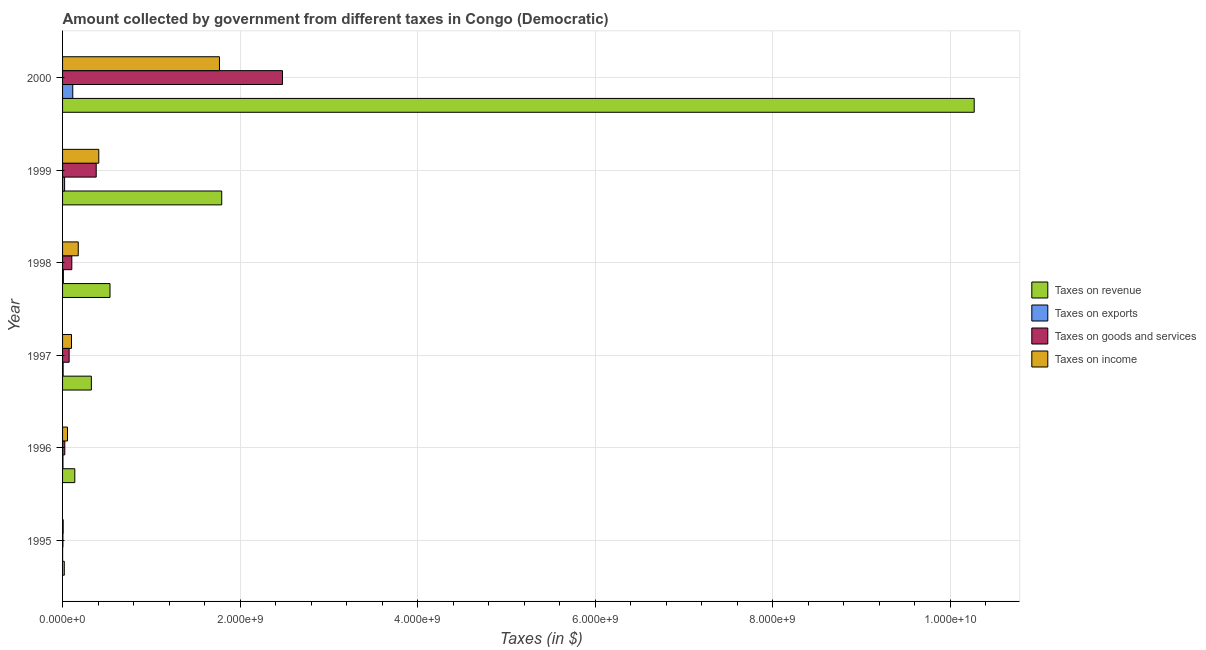How many groups of bars are there?
Your response must be concise. 6. Are the number of bars per tick equal to the number of legend labels?
Provide a short and direct response. Yes. Are the number of bars on each tick of the Y-axis equal?
Your response must be concise. Yes. How many bars are there on the 3rd tick from the top?
Your response must be concise. 4. How many bars are there on the 5th tick from the bottom?
Ensure brevity in your answer.  4. What is the amount collected as tax on revenue in 1996?
Keep it short and to the point. 1.38e+08. Across all years, what is the maximum amount collected as tax on goods?
Provide a short and direct response. 2.48e+09. Across all years, what is the minimum amount collected as tax on goods?
Provide a short and direct response. 3.96e+06. What is the total amount collected as tax on revenue in the graph?
Make the answer very short. 1.31e+1. What is the difference between the amount collected as tax on income in 1996 and that in 1997?
Make the answer very short. -4.52e+07. What is the difference between the amount collected as tax on exports in 1998 and the amount collected as tax on revenue in 1996?
Give a very brief answer. -1.29e+08. What is the average amount collected as tax on exports per year?
Ensure brevity in your answer.  2.64e+07. In the year 1996, what is the difference between the amount collected as tax on income and amount collected as tax on goods?
Provide a short and direct response. 3.03e+07. In how many years, is the amount collected as tax on income greater than 8800000000 $?
Ensure brevity in your answer.  0. What is the ratio of the amount collected as tax on revenue in 1997 to that in 2000?
Offer a very short reply. 0.03. Is the amount collected as tax on exports in 1996 less than that in 1998?
Your answer should be very brief. Yes. What is the difference between the highest and the second highest amount collected as tax on goods?
Keep it short and to the point. 2.10e+09. What is the difference between the highest and the lowest amount collected as tax on income?
Your answer should be compact. 1.76e+09. Is the sum of the amount collected as tax on revenue in 1995 and 1999 greater than the maximum amount collected as tax on income across all years?
Provide a succinct answer. Yes. What does the 4th bar from the top in 1995 represents?
Make the answer very short. Taxes on revenue. What does the 2nd bar from the bottom in 1998 represents?
Provide a succinct answer. Taxes on exports. Is it the case that in every year, the sum of the amount collected as tax on revenue and amount collected as tax on exports is greater than the amount collected as tax on goods?
Offer a very short reply. Yes. How many bars are there?
Ensure brevity in your answer.  24. Are all the bars in the graph horizontal?
Offer a very short reply. Yes. How many years are there in the graph?
Provide a short and direct response. 6. Are the values on the major ticks of X-axis written in scientific E-notation?
Give a very brief answer. Yes. Does the graph contain grids?
Keep it short and to the point. Yes. Where does the legend appear in the graph?
Ensure brevity in your answer.  Center right. What is the title of the graph?
Offer a very short reply. Amount collected by government from different taxes in Congo (Democratic). Does "Finland" appear as one of the legend labels in the graph?
Provide a short and direct response. No. What is the label or title of the X-axis?
Ensure brevity in your answer.  Taxes (in $). What is the Taxes (in $) of Taxes on revenue in 1995?
Give a very brief answer. 1.96e+07. What is the Taxes (in $) in Taxes on goods and services in 1995?
Offer a terse response. 3.96e+06. What is the Taxes (in $) in Taxes on revenue in 1996?
Offer a terse response. 1.38e+08. What is the Taxes (in $) in Taxes on exports in 1996?
Your answer should be compact. 4.53e+06. What is the Taxes (in $) of Taxes on goods and services in 1996?
Give a very brief answer. 2.52e+07. What is the Taxes (in $) of Taxes on income in 1996?
Give a very brief answer. 5.55e+07. What is the Taxes (in $) of Taxes on revenue in 1997?
Your answer should be very brief. 3.24e+08. What is the Taxes (in $) in Taxes on exports in 1997?
Offer a very short reply. 6.24e+06. What is the Taxes (in $) in Taxes on goods and services in 1997?
Ensure brevity in your answer.  7.41e+07. What is the Taxes (in $) of Taxes on income in 1997?
Give a very brief answer. 1.01e+08. What is the Taxes (in $) in Taxes on revenue in 1998?
Keep it short and to the point. 5.34e+08. What is the Taxes (in $) of Taxes on exports in 1998?
Provide a short and direct response. 9.11e+06. What is the Taxes (in $) of Taxes on goods and services in 1998?
Offer a terse response. 1.04e+08. What is the Taxes (in $) in Taxes on income in 1998?
Make the answer very short. 1.77e+08. What is the Taxes (in $) of Taxes on revenue in 1999?
Offer a very short reply. 1.79e+09. What is the Taxes (in $) in Taxes on exports in 1999?
Ensure brevity in your answer.  2.30e+07. What is the Taxes (in $) of Taxes on goods and services in 1999?
Offer a terse response. 3.79e+08. What is the Taxes (in $) of Taxes on income in 1999?
Keep it short and to the point. 4.08e+08. What is the Taxes (in $) in Taxes on revenue in 2000?
Give a very brief answer. 1.03e+1. What is the Taxes (in $) in Taxes on exports in 2000?
Your response must be concise. 1.15e+08. What is the Taxes (in $) in Taxes on goods and services in 2000?
Offer a terse response. 2.48e+09. What is the Taxes (in $) in Taxes on income in 2000?
Offer a very short reply. 1.77e+09. Across all years, what is the maximum Taxes (in $) of Taxes on revenue?
Provide a succinct answer. 1.03e+1. Across all years, what is the maximum Taxes (in $) in Taxes on exports?
Make the answer very short. 1.15e+08. Across all years, what is the maximum Taxes (in $) in Taxes on goods and services?
Your response must be concise. 2.48e+09. Across all years, what is the maximum Taxes (in $) in Taxes on income?
Ensure brevity in your answer.  1.77e+09. Across all years, what is the minimum Taxes (in $) in Taxes on revenue?
Offer a terse response. 1.96e+07. Across all years, what is the minimum Taxes (in $) of Taxes on goods and services?
Provide a succinct answer. 3.96e+06. Across all years, what is the minimum Taxes (in $) in Taxes on income?
Your answer should be very brief. 7.00e+06. What is the total Taxes (in $) of Taxes on revenue in the graph?
Make the answer very short. 1.31e+1. What is the total Taxes (in $) of Taxes on exports in the graph?
Provide a succinct answer. 1.58e+08. What is the total Taxes (in $) in Taxes on goods and services in the graph?
Provide a succinct answer. 3.06e+09. What is the total Taxes (in $) in Taxes on income in the graph?
Give a very brief answer. 2.52e+09. What is the difference between the Taxes (in $) in Taxes on revenue in 1995 and that in 1996?
Give a very brief answer. -1.18e+08. What is the difference between the Taxes (in $) in Taxes on exports in 1995 and that in 1996?
Your answer should be very brief. -4.03e+06. What is the difference between the Taxes (in $) in Taxes on goods and services in 1995 and that in 1996?
Provide a succinct answer. -2.12e+07. What is the difference between the Taxes (in $) of Taxes on income in 1995 and that in 1996?
Your answer should be very brief. -4.85e+07. What is the difference between the Taxes (in $) of Taxes on revenue in 1995 and that in 1997?
Provide a short and direct response. -3.05e+08. What is the difference between the Taxes (in $) of Taxes on exports in 1995 and that in 1997?
Make the answer very short. -5.74e+06. What is the difference between the Taxes (in $) of Taxes on goods and services in 1995 and that in 1997?
Give a very brief answer. -7.01e+07. What is the difference between the Taxes (in $) in Taxes on income in 1995 and that in 1997?
Make the answer very short. -9.37e+07. What is the difference between the Taxes (in $) of Taxes on revenue in 1995 and that in 1998?
Give a very brief answer. -5.15e+08. What is the difference between the Taxes (in $) in Taxes on exports in 1995 and that in 1998?
Your answer should be very brief. -8.61e+06. What is the difference between the Taxes (in $) in Taxes on goods and services in 1995 and that in 1998?
Your answer should be very brief. -1.00e+08. What is the difference between the Taxes (in $) of Taxes on income in 1995 and that in 1998?
Give a very brief answer. -1.70e+08. What is the difference between the Taxes (in $) of Taxes on revenue in 1995 and that in 1999?
Provide a succinct answer. -1.77e+09. What is the difference between the Taxes (in $) of Taxes on exports in 1995 and that in 1999?
Make the answer very short. -2.25e+07. What is the difference between the Taxes (in $) in Taxes on goods and services in 1995 and that in 1999?
Your answer should be very brief. -3.75e+08. What is the difference between the Taxes (in $) in Taxes on income in 1995 and that in 1999?
Your answer should be very brief. -4.01e+08. What is the difference between the Taxes (in $) in Taxes on revenue in 1995 and that in 2000?
Your answer should be compact. -1.02e+1. What is the difference between the Taxes (in $) in Taxes on exports in 1995 and that in 2000?
Offer a very short reply. -1.14e+08. What is the difference between the Taxes (in $) of Taxes on goods and services in 1995 and that in 2000?
Your answer should be compact. -2.47e+09. What is the difference between the Taxes (in $) in Taxes on income in 1995 and that in 2000?
Keep it short and to the point. -1.76e+09. What is the difference between the Taxes (in $) in Taxes on revenue in 1996 and that in 1997?
Ensure brevity in your answer.  -1.86e+08. What is the difference between the Taxes (in $) of Taxes on exports in 1996 and that in 1997?
Make the answer very short. -1.71e+06. What is the difference between the Taxes (in $) in Taxes on goods and services in 1996 and that in 1997?
Offer a terse response. -4.89e+07. What is the difference between the Taxes (in $) in Taxes on income in 1996 and that in 1997?
Give a very brief answer. -4.52e+07. What is the difference between the Taxes (in $) of Taxes on revenue in 1996 and that in 1998?
Make the answer very short. -3.97e+08. What is the difference between the Taxes (in $) of Taxes on exports in 1996 and that in 1998?
Offer a very short reply. -4.58e+06. What is the difference between the Taxes (in $) in Taxes on goods and services in 1996 and that in 1998?
Provide a short and direct response. -7.90e+07. What is the difference between the Taxes (in $) of Taxes on income in 1996 and that in 1998?
Make the answer very short. -1.21e+08. What is the difference between the Taxes (in $) in Taxes on revenue in 1996 and that in 1999?
Provide a short and direct response. -1.66e+09. What is the difference between the Taxes (in $) of Taxes on exports in 1996 and that in 1999?
Your answer should be compact. -1.85e+07. What is the difference between the Taxes (in $) of Taxes on goods and services in 1996 and that in 1999?
Your answer should be very brief. -3.54e+08. What is the difference between the Taxes (in $) of Taxes on income in 1996 and that in 1999?
Provide a succinct answer. -3.52e+08. What is the difference between the Taxes (in $) of Taxes on revenue in 1996 and that in 2000?
Make the answer very short. -1.01e+1. What is the difference between the Taxes (in $) of Taxes on exports in 1996 and that in 2000?
Your answer should be very brief. -1.10e+08. What is the difference between the Taxes (in $) in Taxes on goods and services in 1996 and that in 2000?
Your answer should be compact. -2.45e+09. What is the difference between the Taxes (in $) in Taxes on income in 1996 and that in 2000?
Keep it short and to the point. -1.71e+09. What is the difference between the Taxes (in $) of Taxes on revenue in 1997 and that in 1998?
Offer a very short reply. -2.10e+08. What is the difference between the Taxes (in $) in Taxes on exports in 1997 and that in 1998?
Keep it short and to the point. -2.87e+06. What is the difference between the Taxes (in $) in Taxes on goods and services in 1997 and that in 1998?
Give a very brief answer. -3.02e+07. What is the difference between the Taxes (in $) in Taxes on income in 1997 and that in 1998?
Keep it short and to the point. -7.60e+07. What is the difference between the Taxes (in $) in Taxes on revenue in 1997 and that in 1999?
Ensure brevity in your answer.  -1.47e+09. What is the difference between the Taxes (in $) in Taxes on exports in 1997 and that in 1999?
Provide a short and direct response. -1.68e+07. What is the difference between the Taxes (in $) in Taxes on goods and services in 1997 and that in 1999?
Give a very brief answer. -3.05e+08. What is the difference between the Taxes (in $) of Taxes on income in 1997 and that in 1999?
Ensure brevity in your answer.  -3.07e+08. What is the difference between the Taxes (in $) in Taxes on revenue in 1997 and that in 2000?
Ensure brevity in your answer.  -9.94e+09. What is the difference between the Taxes (in $) of Taxes on exports in 1997 and that in 2000?
Your response must be concise. -1.09e+08. What is the difference between the Taxes (in $) in Taxes on goods and services in 1997 and that in 2000?
Your answer should be compact. -2.40e+09. What is the difference between the Taxes (in $) in Taxes on income in 1997 and that in 2000?
Your answer should be very brief. -1.67e+09. What is the difference between the Taxes (in $) of Taxes on revenue in 1998 and that in 1999?
Make the answer very short. -1.26e+09. What is the difference between the Taxes (in $) of Taxes on exports in 1998 and that in 1999?
Keep it short and to the point. -1.39e+07. What is the difference between the Taxes (in $) in Taxes on goods and services in 1998 and that in 1999?
Provide a succinct answer. -2.75e+08. What is the difference between the Taxes (in $) of Taxes on income in 1998 and that in 1999?
Provide a short and direct response. -2.31e+08. What is the difference between the Taxes (in $) of Taxes on revenue in 1998 and that in 2000?
Provide a succinct answer. -9.73e+09. What is the difference between the Taxes (in $) of Taxes on exports in 1998 and that in 2000?
Offer a terse response. -1.06e+08. What is the difference between the Taxes (in $) in Taxes on goods and services in 1998 and that in 2000?
Keep it short and to the point. -2.37e+09. What is the difference between the Taxes (in $) in Taxes on income in 1998 and that in 2000?
Keep it short and to the point. -1.59e+09. What is the difference between the Taxes (in $) of Taxes on revenue in 1999 and that in 2000?
Your response must be concise. -8.48e+09. What is the difference between the Taxes (in $) in Taxes on exports in 1999 and that in 2000?
Your answer should be compact. -9.19e+07. What is the difference between the Taxes (in $) in Taxes on goods and services in 1999 and that in 2000?
Offer a terse response. -2.10e+09. What is the difference between the Taxes (in $) in Taxes on income in 1999 and that in 2000?
Make the answer very short. -1.36e+09. What is the difference between the Taxes (in $) in Taxes on revenue in 1995 and the Taxes (in $) in Taxes on exports in 1996?
Provide a succinct answer. 1.50e+07. What is the difference between the Taxes (in $) of Taxes on revenue in 1995 and the Taxes (in $) of Taxes on goods and services in 1996?
Keep it short and to the point. -5.65e+06. What is the difference between the Taxes (in $) in Taxes on revenue in 1995 and the Taxes (in $) in Taxes on income in 1996?
Make the answer very short. -3.60e+07. What is the difference between the Taxes (in $) in Taxes on exports in 1995 and the Taxes (in $) in Taxes on goods and services in 1996?
Offer a very short reply. -2.47e+07. What is the difference between the Taxes (in $) of Taxes on exports in 1995 and the Taxes (in $) of Taxes on income in 1996?
Give a very brief answer. -5.50e+07. What is the difference between the Taxes (in $) of Taxes on goods and services in 1995 and the Taxes (in $) of Taxes on income in 1996?
Provide a succinct answer. -5.16e+07. What is the difference between the Taxes (in $) of Taxes on revenue in 1995 and the Taxes (in $) of Taxes on exports in 1997?
Provide a succinct answer. 1.33e+07. What is the difference between the Taxes (in $) of Taxes on revenue in 1995 and the Taxes (in $) of Taxes on goods and services in 1997?
Ensure brevity in your answer.  -5.45e+07. What is the difference between the Taxes (in $) of Taxes on revenue in 1995 and the Taxes (in $) of Taxes on income in 1997?
Your answer should be compact. -8.11e+07. What is the difference between the Taxes (in $) in Taxes on exports in 1995 and the Taxes (in $) in Taxes on goods and services in 1997?
Your response must be concise. -7.36e+07. What is the difference between the Taxes (in $) of Taxes on exports in 1995 and the Taxes (in $) of Taxes on income in 1997?
Your response must be concise. -1.00e+08. What is the difference between the Taxes (in $) in Taxes on goods and services in 1995 and the Taxes (in $) in Taxes on income in 1997?
Keep it short and to the point. -9.67e+07. What is the difference between the Taxes (in $) in Taxes on revenue in 1995 and the Taxes (in $) in Taxes on exports in 1998?
Keep it short and to the point. 1.04e+07. What is the difference between the Taxes (in $) in Taxes on revenue in 1995 and the Taxes (in $) in Taxes on goods and services in 1998?
Provide a succinct answer. -8.47e+07. What is the difference between the Taxes (in $) of Taxes on revenue in 1995 and the Taxes (in $) of Taxes on income in 1998?
Your response must be concise. -1.57e+08. What is the difference between the Taxes (in $) of Taxes on exports in 1995 and the Taxes (in $) of Taxes on goods and services in 1998?
Your answer should be very brief. -1.04e+08. What is the difference between the Taxes (in $) of Taxes on exports in 1995 and the Taxes (in $) of Taxes on income in 1998?
Provide a succinct answer. -1.76e+08. What is the difference between the Taxes (in $) in Taxes on goods and services in 1995 and the Taxes (in $) in Taxes on income in 1998?
Ensure brevity in your answer.  -1.73e+08. What is the difference between the Taxes (in $) in Taxes on revenue in 1995 and the Taxes (in $) in Taxes on exports in 1999?
Provide a short and direct response. -3.45e+06. What is the difference between the Taxes (in $) of Taxes on revenue in 1995 and the Taxes (in $) of Taxes on goods and services in 1999?
Your answer should be very brief. -3.59e+08. What is the difference between the Taxes (in $) of Taxes on revenue in 1995 and the Taxes (in $) of Taxes on income in 1999?
Provide a short and direct response. -3.88e+08. What is the difference between the Taxes (in $) in Taxes on exports in 1995 and the Taxes (in $) in Taxes on goods and services in 1999?
Your response must be concise. -3.78e+08. What is the difference between the Taxes (in $) of Taxes on exports in 1995 and the Taxes (in $) of Taxes on income in 1999?
Provide a succinct answer. -4.08e+08. What is the difference between the Taxes (in $) of Taxes on goods and services in 1995 and the Taxes (in $) of Taxes on income in 1999?
Give a very brief answer. -4.04e+08. What is the difference between the Taxes (in $) in Taxes on revenue in 1995 and the Taxes (in $) in Taxes on exports in 2000?
Your response must be concise. -9.53e+07. What is the difference between the Taxes (in $) in Taxes on revenue in 1995 and the Taxes (in $) in Taxes on goods and services in 2000?
Your response must be concise. -2.46e+09. What is the difference between the Taxes (in $) in Taxes on revenue in 1995 and the Taxes (in $) in Taxes on income in 2000?
Make the answer very short. -1.75e+09. What is the difference between the Taxes (in $) of Taxes on exports in 1995 and the Taxes (in $) of Taxes on goods and services in 2000?
Keep it short and to the point. -2.48e+09. What is the difference between the Taxes (in $) in Taxes on exports in 1995 and the Taxes (in $) in Taxes on income in 2000?
Give a very brief answer. -1.77e+09. What is the difference between the Taxes (in $) in Taxes on goods and services in 1995 and the Taxes (in $) in Taxes on income in 2000?
Offer a terse response. -1.76e+09. What is the difference between the Taxes (in $) in Taxes on revenue in 1996 and the Taxes (in $) in Taxes on exports in 1997?
Keep it short and to the point. 1.32e+08. What is the difference between the Taxes (in $) of Taxes on revenue in 1996 and the Taxes (in $) of Taxes on goods and services in 1997?
Ensure brevity in your answer.  6.38e+07. What is the difference between the Taxes (in $) of Taxes on revenue in 1996 and the Taxes (in $) of Taxes on income in 1997?
Provide a succinct answer. 3.72e+07. What is the difference between the Taxes (in $) of Taxes on exports in 1996 and the Taxes (in $) of Taxes on goods and services in 1997?
Provide a succinct answer. -6.95e+07. What is the difference between the Taxes (in $) of Taxes on exports in 1996 and the Taxes (in $) of Taxes on income in 1997?
Keep it short and to the point. -9.62e+07. What is the difference between the Taxes (in $) of Taxes on goods and services in 1996 and the Taxes (in $) of Taxes on income in 1997?
Make the answer very short. -7.55e+07. What is the difference between the Taxes (in $) in Taxes on revenue in 1996 and the Taxes (in $) in Taxes on exports in 1998?
Ensure brevity in your answer.  1.29e+08. What is the difference between the Taxes (in $) in Taxes on revenue in 1996 and the Taxes (in $) in Taxes on goods and services in 1998?
Offer a terse response. 3.36e+07. What is the difference between the Taxes (in $) of Taxes on revenue in 1996 and the Taxes (in $) of Taxes on income in 1998?
Give a very brief answer. -3.88e+07. What is the difference between the Taxes (in $) of Taxes on exports in 1996 and the Taxes (in $) of Taxes on goods and services in 1998?
Your answer should be very brief. -9.97e+07. What is the difference between the Taxes (in $) in Taxes on exports in 1996 and the Taxes (in $) in Taxes on income in 1998?
Your response must be concise. -1.72e+08. What is the difference between the Taxes (in $) in Taxes on goods and services in 1996 and the Taxes (in $) in Taxes on income in 1998?
Provide a short and direct response. -1.52e+08. What is the difference between the Taxes (in $) of Taxes on revenue in 1996 and the Taxes (in $) of Taxes on exports in 1999?
Provide a succinct answer. 1.15e+08. What is the difference between the Taxes (in $) in Taxes on revenue in 1996 and the Taxes (in $) in Taxes on goods and services in 1999?
Your answer should be very brief. -2.41e+08. What is the difference between the Taxes (in $) of Taxes on revenue in 1996 and the Taxes (in $) of Taxes on income in 1999?
Provide a succinct answer. -2.70e+08. What is the difference between the Taxes (in $) in Taxes on exports in 1996 and the Taxes (in $) in Taxes on goods and services in 1999?
Provide a succinct answer. -3.74e+08. What is the difference between the Taxes (in $) in Taxes on exports in 1996 and the Taxes (in $) in Taxes on income in 1999?
Give a very brief answer. -4.03e+08. What is the difference between the Taxes (in $) in Taxes on goods and services in 1996 and the Taxes (in $) in Taxes on income in 1999?
Your response must be concise. -3.83e+08. What is the difference between the Taxes (in $) of Taxes on revenue in 1996 and the Taxes (in $) of Taxes on exports in 2000?
Offer a very short reply. 2.30e+07. What is the difference between the Taxes (in $) of Taxes on revenue in 1996 and the Taxes (in $) of Taxes on goods and services in 2000?
Keep it short and to the point. -2.34e+09. What is the difference between the Taxes (in $) of Taxes on revenue in 1996 and the Taxes (in $) of Taxes on income in 2000?
Your answer should be compact. -1.63e+09. What is the difference between the Taxes (in $) in Taxes on exports in 1996 and the Taxes (in $) in Taxes on goods and services in 2000?
Provide a short and direct response. -2.47e+09. What is the difference between the Taxes (in $) of Taxes on exports in 1996 and the Taxes (in $) of Taxes on income in 2000?
Make the answer very short. -1.76e+09. What is the difference between the Taxes (in $) in Taxes on goods and services in 1996 and the Taxes (in $) in Taxes on income in 2000?
Ensure brevity in your answer.  -1.74e+09. What is the difference between the Taxes (in $) of Taxes on revenue in 1997 and the Taxes (in $) of Taxes on exports in 1998?
Your answer should be compact. 3.15e+08. What is the difference between the Taxes (in $) of Taxes on revenue in 1997 and the Taxes (in $) of Taxes on goods and services in 1998?
Your answer should be very brief. 2.20e+08. What is the difference between the Taxes (in $) of Taxes on revenue in 1997 and the Taxes (in $) of Taxes on income in 1998?
Offer a terse response. 1.48e+08. What is the difference between the Taxes (in $) of Taxes on exports in 1997 and the Taxes (in $) of Taxes on goods and services in 1998?
Your answer should be compact. -9.80e+07. What is the difference between the Taxes (in $) of Taxes on exports in 1997 and the Taxes (in $) of Taxes on income in 1998?
Your response must be concise. -1.70e+08. What is the difference between the Taxes (in $) in Taxes on goods and services in 1997 and the Taxes (in $) in Taxes on income in 1998?
Offer a terse response. -1.03e+08. What is the difference between the Taxes (in $) in Taxes on revenue in 1997 and the Taxes (in $) in Taxes on exports in 1999?
Give a very brief answer. 3.01e+08. What is the difference between the Taxes (in $) in Taxes on revenue in 1997 and the Taxes (in $) in Taxes on goods and services in 1999?
Your answer should be compact. -5.47e+07. What is the difference between the Taxes (in $) of Taxes on revenue in 1997 and the Taxes (in $) of Taxes on income in 1999?
Your response must be concise. -8.37e+07. What is the difference between the Taxes (in $) of Taxes on exports in 1997 and the Taxes (in $) of Taxes on goods and services in 1999?
Give a very brief answer. -3.73e+08. What is the difference between the Taxes (in $) of Taxes on exports in 1997 and the Taxes (in $) of Taxes on income in 1999?
Offer a terse response. -4.02e+08. What is the difference between the Taxes (in $) in Taxes on goods and services in 1997 and the Taxes (in $) in Taxes on income in 1999?
Give a very brief answer. -3.34e+08. What is the difference between the Taxes (in $) in Taxes on revenue in 1997 and the Taxes (in $) in Taxes on exports in 2000?
Your answer should be very brief. 2.09e+08. What is the difference between the Taxes (in $) of Taxes on revenue in 1997 and the Taxes (in $) of Taxes on goods and services in 2000?
Your answer should be very brief. -2.15e+09. What is the difference between the Taxes (in $) of Taxes on revenue in 1997 and the Taxes (in $) of Taxes on income in 2000?
Make the answer very short. -1.44e+09. What is the difference between the Taxes (in $) of Taxes on exports in 1997 and the Taxes (in $) of Taxes on goods and services in 2000?
Provide a short and direct response. -2.47e+09. What is the difference between the Taxes (in $) in Taxes on exports in 1997 and the Taxes (in $) in Taxes on income in 2000?
Give a very brief answer. -1.76e+09. What is the difference between the Taxes (in $) in Taxes on goods and services in 1997 and the Taxes (in $) in Taxes on income in 2000?
Provide a succinct answer. -1.69e+09. What is the difference between the Taxes (in $) of Taxes on revenue in 1998 and the Taxes (in $) of Taxes on exports in 1999?
Provide a succinct answer. 5.11e+08. What is the difference between the Taxes (in $) in Taxes on revenue in 1998 and the Taxes (in $) in Taxes on goods and services in 1999?
Your answer should be compact. 1.55e+08. What is the difference between the Taxes (in $) in Taxes on revenue in 1998 and the Taxes (in $) in Taxes on income in 1999?
Ensure brevity in your answer.  1.26e+08. What is the difference between the Taxes (in $) of Taxes on exports in 1998 and the Taxes (in $) of Taxes on goods and services in 1999?
Give a very brief answer. -3.70e+08. What is the difference between the Taxes (in $) of Taxes on exports in 1998 and the Taxes (in $) of Taxes on income in 1999?
Provide a succinct answer. -3.99e+08. What is the difference between the Taxes (in $) of Taxes on goods and services in 1998 and the Taxes (in $) of Taxes on income in 1999?
Provide a short and direct response. -3.04e+08. What is the difference between the Taxes (in $) of Taxes on revenue in 1998 and the Taxes (in $) of Taxes on exports in 2000?
Offer a terse response. 4.20e+08. What is the difference between the Taxes (in $) in Taxes on revenue in 1998 and the Taxes (in $) in Taxes on goods and services in 2000?
Your answer should be compact. -1.94e+09. What is the difference between the Taxes (in $) in Taxes on revenue in 1998 and the Taxes (in $) in Taxes on income in 2000?
Offer a very short reply. -1.23e+09. What is the difference between the Taxes (in $) in Taxes on exports in 1998 and the Taxes (in $) in Taxes on goods and services in 2000?
Ensure brevity in your answer.  -2.47e+09. What is the difference between the Taxes (in $) in Taxes on exports in 1998 and the Taxes (in $) in Taxes on income in 2000?
Give a very brief answer. -1.76e+09. What is the difference between the Taxes (in $) in Taxes on goods and services in 1998 and the Taxes (in $) in Taxes on income in 2000?
Keep it short and to the point. -1.66e+09. What is the difference between the Taxes (in $) in Taxes on revenue in 1999 and the Taxes (in $) in Taxes on exports in 2000?
Your answer should be very brief. 1.68e+09. What is the difference between the Taxes (in $) in Taxes on revenue in 1999 and the Taxes (in $) in Taxes on goods and services in 2000?
Offer a terse response. -6.84e+08. What is the difference between the Taxes (in $) of Taxes on revenue in 1999 and the Taxes (in $) of Taxes on income in 2000?
Offer a very short reply. 2.56e+07. What is the difference between the Taxes (in $) of Taxes on exports in 1999 and the Taxes (in $) of Taxes on goods and services in 2000?
Ensure brevity in your answer.  -2.45e+09. What is the difference between the Taxes (in $) of Taxes on exports in 1999 and the Taxes (in $) of Taxes on income in 2000?
Ensure brevity in your answer.  -1.74e+09. What is the difference between the Taxes (in $) in Taxes on goods and services in 1999 and the Taxes (in $) in Taxes on income in 2000?
Give a very brief answer. -1.39e+09. What is the average Taxes (in $) in Taxes on revenue per year?
Keep it short and to the point. 2.18e+09. What is the average Taxes (in $) in Taxes on exports per year?
Your answer should be compact. 2.64e+07. What is the average Taxes (in $) of Taxes on goods and services per year?
Give a very brief answer. 5.11e+08. What is the average Taxes (in $) in Taxes on income per year?
Provide a succinct answer. 4.19e+08. In the year 1995, what is the difference between the Taxes (in $) of Taxes on revenue and Taxes (in $) of Taxes on exports?
Provide a short and direct response. 1.90e+07. In the year 1995, what is the difference between the Taxes (in $) of Taxes on revenue and Taxes (in $) of Taxes on goods and services?
Keep it short and to the point. 1.56e+07. In the year 1995, what is the difference between the Taxes (in $) of Taxes on revenue and Taxes (in $) of Taxes on income?
Offer a terse response. 1.26e+07. In the year 1995, what is the difference between the Taxes (in $) in Taxes on exports and Taxes (in $) in Taxes on goods and services?
Your answer should be compact. -3.46e+06. In the year 1995, what is the difference between the Taxes (in $) in Taxes on exports and Taxes (in $) in Taxes on income?
Provide a succinct answer. -6.50e+06. In the year 1995, what is the difference between the Taxes (in $) in Taxes on goods and services and Taxes (in $) in Taxes on income?
Ensure brevity in your answer.  -3.04e+06. In the year 1996, what is the difference between the Taxes (in $) in Taxes on revenue and Taxes (in $) in Taxes on exports?
Provide a succinct answer. 1.33e+08. In the year 1996, what is the difference between the Taxes (in $) in Taxes on revenue and Taxes (in $) in Taxes on goods and services?
Make the answer very short. 1.13e+08. In the year 1996, what is the difference between the Taxes (in $) in Taxes on revenue and Taxes (in $) in Taxes on income?
Ensure brevity in your answer.  8.24e+07. In the year 1996, what is the difference between the Taxes (in $) in Taxes on exports and Taxes (in $) in Taxes on goods and services?
Give a very brief answer. -2.07e+07. In the year 1996, what is the difference between the Taxes (in $) of Taxes on exports and Taxes (in $) of Taxes on income?
Your answer should be compact. -5.10e+07. In the year 1996, what is the difference between the Taxes (in $) of Taxes on goods and services and Taxes (in $) of Taxes on income?
Offer a very short reply. -3.03e+07. In the year 1997, what is the difference between the Taxes (in $) of Taxes on revenue and Taxes (in $) of Taxes on exports?
Ensure brevity in your answer.  3.18e+08. In the year 1997, what is the difference between the Taxes (in $) in Taxes on revenue and Taxes (in $) in Taxes on goods and services?
Make the answer very short. 2.50e+08. In the year 1997, what is the difference between the Taxes (in $) of Taxes on revenue and Taxes (in $) of Taxes on income?
Offer a very short reply. 2.24e+08. In the year 1997, what is the difference between the Taxes (in $) in Taxes on exports and Taxes (in $) in Taxes on goods and services?
Offer a terse response. -6.78e+07. In the year 1997, what is the difference between the Taxes (in $) in Taxes on exports and Taxes (in $) in Taxes on income?
Give a very brief answer. -9.44e+07. In the year 1997, what is the difference between the Taxes (in $) of Taxes on goods and services and Taxes (in $) of Taxes on income?
Make the answer very short. -2.66e+07. In the year 1998, what is the difference between the Taxes (in $) in Taxes on revenue and Taxes (in $) in Taxes on exports?
Provide a succinct answer. 5.25e+08. In the year 1998, what is the difference between the Taxes (in $) of Taxes on revenue and Taxes (in $) of Taxes on goods and services?
Offer a terse response. 4.30e+08. In the year 1998, what is the difference between the Taxes (in $) in Taxes on revenue and Taxes (in $) in Taxes on income?
Ensure brevity in your answer.  3.58e+08. In the year 1998, what is the difference between the Taxes (in $) in Taxes on exports and Taxes (in $) in Taxes on goods and services?
Offer a terse response. -9.51e+07. In the year 1998, what is the difference between the Taxes (in $) in Taxes on exports and Taxes (in $) in Taxes on income?
Offer a terse response. -1.68e+08. In the year 1998, what is the difference between the Taxes (in $) of Taxes on goods and services and Taxes (in $) of Taxes on income?
Your answer should be very brief. -7.25e+07. In the year 1999, what is the difference between the Taxes (in $) of Taxes on revenue and Taxes (in $) of Taxes on exports?
Make the answer very short. 1.77e+09. In the year 1999, what is the difference between the Taxes (in $) of Taxes on revenue and Taxes (in $) of Taxes on goods and services?
Provide a succinct answer. 1.41e+09. In the year 1999, what is the difference between the Taxes (in $) of Taxes on revenue and Taxes (in $) of Taxes on income?
Make the answer very short. 1.38e+09. In the year 1999, what is the difference between the Taxes (in $) in Taxes on exports and Taxes (in $) in Taxes on goods and services?
Your answer should be compact. -3.56e+08. In the year 1999, what is the difference between the Taxes (in $) of Taxes on exports and Taxes (in $) of Taxes on income?
Give a very brief answer. -3.85e+08. In the year 1999, what is the difference between the Taxes (in $) in Taxes on goods and services and Taxes (in $) in Taxes on income?
Ensure brevity in your answer.  -2.90e+07. In the year 2000, what is the difference between the Taxes (in $) of Taxes on revenue and Taxes (in $) of Taxes on exports?
Make the answer very short. 1.02e+1. In the year 2000, what is the difference between the Taxes (in $) of Taxes on revenue and Taxes (in $) of Taxes on goods and services?
Make the answer very short. 7.79e+09. In the year 2000, what is the difference between the Taxes (in $) in Taxes on revenue and Taxes (in $) in Taxes on income?
Keep it short and to the point. 8.50e+09. In the year 2000, what is the difference between the Taxes (in $) in Taxes on exports and Taxes (in $) in Taxes on goods and services?
Offer a very short reply. -2.36e+09. In the year 2000, what is the difference between the Taxes (in $) of Taxes on exports and Taxes (in $) of Taxes on income?
Your answer should be very brief. -1.65e+09. In the year 2000, what is the difference between the Taxes (in $) of Taxes on goods and services and Taxes (in $) of Taxes on income?
Keep it short and to the point. 7.10e+08. What is the ratio of the Taxes (in $) of Taxes on revenue in 1995 to that in 1996?
Provide a short and direct response. 0.14. What is the ratio of the Taxes (in $) of Taxes on exports in 1995 to that in 1996?
Offer a terse response. 0.11. What is the ratio of the Taxes (in $) in Taxes on goods and services in 1995 to that in 1996?
Your answer should be compact. 0.16. What is the ratio of the Taxes (in $) in Taxes on income in 1995 to that in 1996?
Your answer should be very brief. 0.13. What is the ratio of the Taxes (in $) in Taxes on revenue in 1995 to that in 1997?
Provide a short and direct response. 0.06. What is the ratio of the Taxes (in $) in Taxes on exports in 1995 to that in 1997?
Provide a succinct answer. 0.08. What is the ratio of the Taxes (in $) of Taxes on goods and services in 1995 to that in 1997?
Your response must be concise. 0.05. What is the ratio of the Taxes (in $) of Taxes on income in 1995 to that in 1997?
Offer a terse response. 0.07. What is the ratio of the Taxes (in $) in Taxes on revenue in 1995 to that in 1998?
Keep it short and to the point. 0.04. What is the ratio of the Taxes (in $) in Taxes on exports in 1995 to that in 1998?
Offer a terse response. 0.05. What is the ratio of the Taxes (in $) of Taxes on goods and services in 1995 to that in 1998?
Make the answer very short. 0.04. What is the ratio of the Taxes (in $) in Taxes on income in 1995 to that in 1998?
Provide a succinct answer. 0.04. What is the ratio of the Taxes (in $) of Taxes on revenue in 1995 to that in 1999?
Your answer should be compact. 0.01. What is the ratio of the Taxes (in $) in Taxes on exports in 1995 to that in 1999?
Offer a terse response. 0.02. What is the ratio of the Taxes (in $) of Taxes on goods and services in 1995 to that in 1999?
Provide a short and direct response. 0.01. What is the ratio of the Taxes (in $) in Taxes on income in 1995 to that in 1999?
Your response must be concise. 0.02. What is the ratio of the Taxes (in $) of Taxes on revenue in 1995 to that in 2000?
Provide a succinct answer. 0. What is the ratio of the Taxes (in $) in Taxes on exports in 1995 to that in 2000?
Keep it short and to the point. 0. What is the ratio of the Taxes (in $) in Taxes on goods and services in 1995 to that in 2000?
Provide a succinct answer. 0. What is the ratio of the Taxes (in $) of Taxes on income in 1995 to that in 2000?
Provide a short and direct response. 0. What is the ratio of the Taxes (in $) in Taxes on revenue in 1996 to that in 1997?
Give a very brief answer. 0.43. What is the ratio of the Taxes (in $) in Taxes on exports in 1996 to that in 1997?
Provide a short and direct response. 0.73. What is the ratio of the Taxes (in $) in Taxes on goods and services in 1996 to that in 1997?
Make the answer very short. 0.34. What is the ratio of the Taxes (in $) in Taxes on income in 1996 to that in 1997?
Provide a succinct answer. 0.55. What is the ratio of the Taxes (in $) in Taxes on revenue in 1996 to that in 1998?
Keep it short and to the point. 0.26. What is the ratio of the Taxes (in $) in Taxes on exports in 1996 to that in 1998?
Your answer should be compact. 0.5. What is the ratio of the Taxes (in $) of Taxes on goods and services in 1996 to that in 1998?
Give a very brief answer. 0.24. What is the ratio of the Taxes (in $) in Taxes on income in 1996 to that in 1998?
Provide a succinct answer. 0.31. What is the ratio of the Taxes (in $) in Taxes on revenue in 1996 to that in 1999?
Your answer should be compact. 0.08. What is the ratio of the Taxes (in $) of Taxes on exports in 1996 to that in 1999?
Your answer should be compact. 0.2. What is the ratio of the Taxes (in $) in Taxes on goods and services in 1996 to that in 1999?
Ensure brevity in your answer.  0.07. What is the ratio of the Taxes (in $) of Taxes on income in 1996 to that in 1999?
Offer a terse response. 0.14. What is the ratio of the Taxes (in $) of Taxes on revenue in 1996 to that in 2000?
Keep it short and to the point. 0.01. What is the ratio of the Taxes (in $) in Taxes on exports in 1996 to that in 2000?
Provide a short and direct response. 0.04. What is the ratio of the Taxes (in $) in Taxes on goods and services in 1996 to that in 2000?
Your answer should be compact. 0.01. What is the ratio of the Taxes (in $) in Taxes on income in 1996 to that in 2000?
Offer a terse response. 0.03. What is the ratio of the Taxes (in $) of Taxes on revenue in 1997 to that in 1998?
Offer a very short reply. 0.61. What is the ratio of the Taxes (in $) in Taxes on exports in 1997 to that in 1998?
Keep it short and to the point. 0.68. What is the ratio of the Taxes (in $) of Taxes on goods and services in 1997 to that in 1998?
Provide a succinct answer. 0.71. What is the ratio of the Taxes (in $) in Taxes on income in 1997 to that in 1998?
Your response must be concise. 0.57. What is the ratio of the Taxes (in $) of Taxes on revenue in 1997 to that in 1999?
Keep it short and to the point. 0.18. What is the ratio of the Taxes (in $) in Taxes on exports in 1997 to that in 1999?
Your response must be concise. 0.27. What is the ratio of the Taxes (in $) in Taxes on goods and services in 1997 to that in 1999?
Offer a very short reply. 0.2. What is the ratio of the Taxes (in $) of Taxes on income in 1997 to that in 1999?
Offer a terse response. 0.25. What is the ratio of the Taxes (in $) of Taxes on revenue in 1997 to that in 2000?
Offer a terse response. 0.03. What is the ratio of the Taxes (in $) in Taxes on exports in 1997 to that in 2000?
Give a very brief answer. 0.05. What is the ratio of the Taxes (in $) in Taxes on goods and services in 1997 to that in 2000?
Provide a short and direct response. 0.03. What is the ratio of the Taxes (in $) of Taxes on income in 1997 to that in 2000?
Your answer should be very brief. 0.06. What is the ratio of the Taxes (in $) in Taxes on revenue in 1998 to that in 1999?
Ensure brevity in your answer.  0.3. What is the ratio of the Taxes (in $) in Taxes on exports in 1998 to that in 1999?
Ensure brevity in your answer.  0.4. What is the ratio of the Taxes (in $) of Taxes on goods and services in 1998 to that in 1999?
Keep it short and to the point. 0.28. What is the ratio of the Taxes (in $) in Taxes on income in 1998 to that in 1999?
Make the answer very short. 0.43. What is the ratio of the Taxes (in $) of Taxes on revenue in 1998 to that in 2000?
Provide a short and direct response. 0.05. What is the ratio of the Taxes (in $) of Taxes on exports in 1998 to that in 2000?
Ensure brevity in your answer.  0.08. What is the ratio of the Taxes (in $) in Taxes on goods and services in 1998 to that in 2000?
Offer a very short reply. 0.04. What is the ratio of the Taxes (in $) in Taxes on income in 1998 to that in 2000?
Provide a short and direct response. 0.1. What is the ratio of the Taxes (in $) of Taxes on revenue in 1999 to that in 2000?
Your answer should be very brief. 0.17. What is the ratio of the Taxes (in $) of Taxes on exports in 1999 to that in 2000?
Make the answer very short. 0.2. What is the ratio of the Taxes (in $) of Taxes on goods and services in 1999 to that in 2000?
Offer a terse response. 0.15. What is the ratio of the Taxes (in $) of Taxes on income in 1999 to that in 2000?
Offer a terse response. 0.23. What is the difference between the highest and the second highest Taxes (in $) of Taxes on revenue?
Your response must be concise. 8.48e+09. What is the difference between the highest and the second highest Taxes (in $) in Taxes on exports?
Your answer should be very brief. 9.19e+07. What is the difference between the highest and the second highest Taxes (in $) of Taxes on goods and services?
Offer a very short reply. 2.10e+09. What is the difference between the highest and the second highest Taxes (in $) in Taxes on income?
Offer a terse response. 1.36e+09. What is the difference between the highest and the lowest Taxes (in $) in Taxes on revenue?
Make the answer very short. 1.02e+1. What is the difference between the highest and the lowest Taxes (in $) in Taxes on exports?
Provide a short and direct response. 1.14e+08. What is the difference between the highest and the lowest Taxes (in $) of Taxes on goods and services?
Provide a short and direct response. 2.47e+09. What is the difference between the highest and the lowest Taxes (in $) of Taxes on income?
Give a very brief answer. 1.76e+09. 